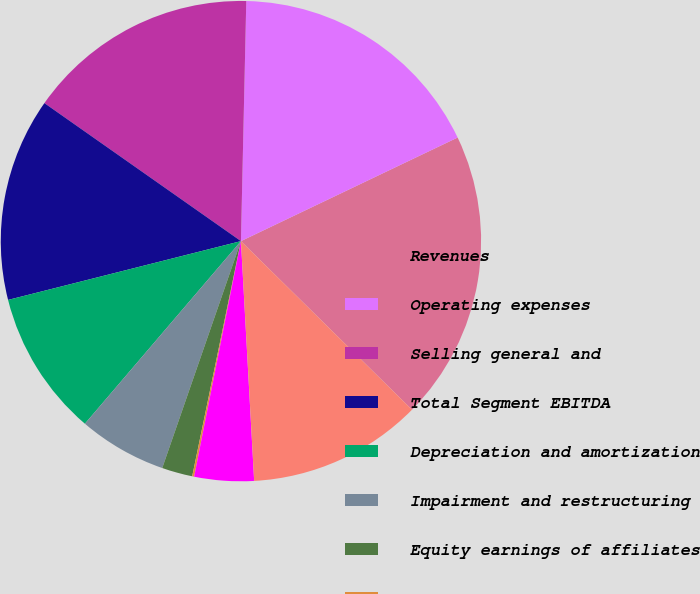<chart> <loc_0><loc_0><loc_500><loc_500><pie_chart><fcel>Revenues<fcel>Operating expenses<fcel>Selling general and<fcel>Total Segment EBITDA<fcel>Depreciation and amortization<fcel>Impairment and restructuring<fcel>Equity earnings of affiliates<fcel>Interest net<fcel>Other net<fcel>Income from continuing<nl><fcel>19.48%<fcel>17.55%<fcel>15.61%<fcel>13.68%<fcel>9.81%<fcel>5.94%<fcel>2.06%<fcel>0.13%<fcel>4.0%<fcel>11.74%<nl></chart> 